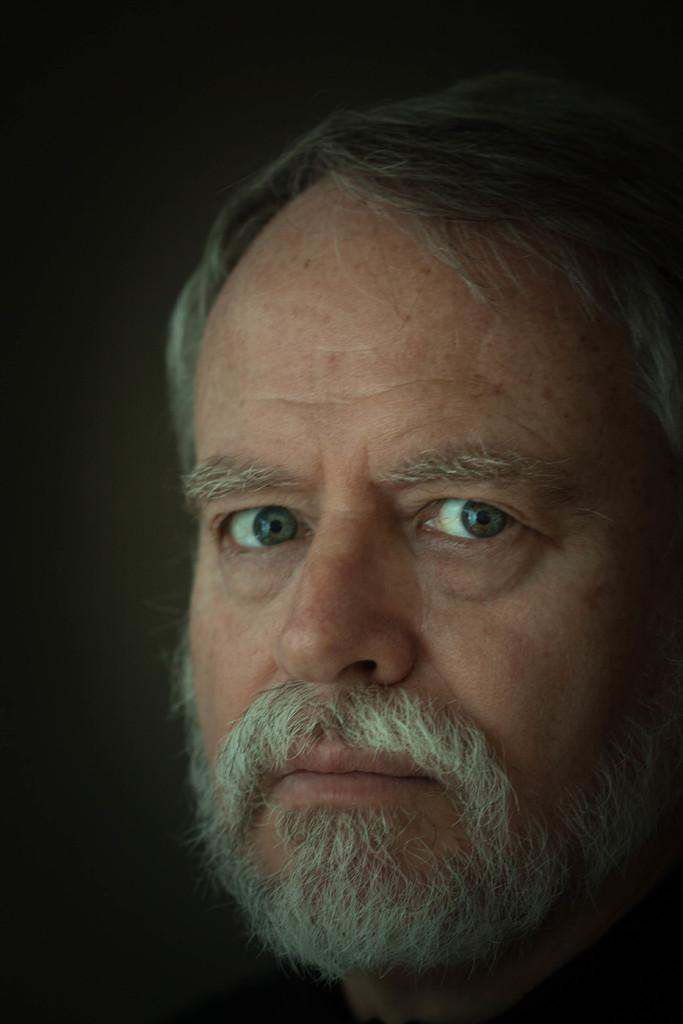What is the main subject of the image? There is a person in the image. Can you describe the background of the image? The background of the image is dark. How many parcels are being carried by the person in the image? There is no mention of parcels in the image, so it cannot be determined if any are being carried. 